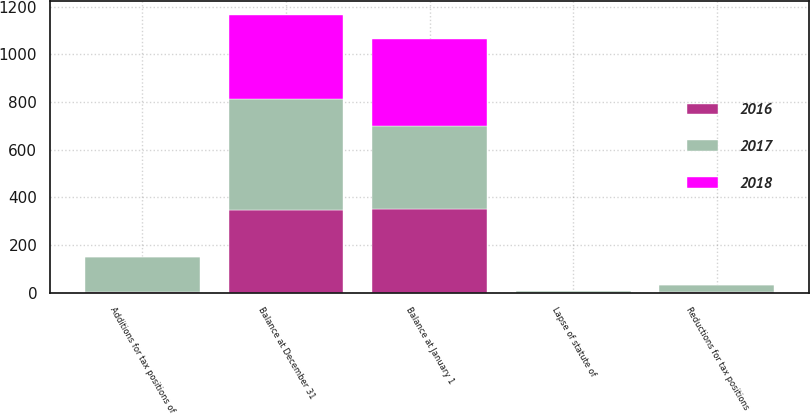<chart> <loc_0><loc_0><loc_500><loc_500><stacked_bar_chart><ecel><fcel>Balance at January 1<fcel>Additions for tax positions of<fcel>Reductions for tax positions<fcel>Lapse of statute of<fcel>Balance at December 31<nl><fcel>2017<fcel>348<fcel>146<fcel>26<fcel>7<fcel>463<nl><fcel>2016<fcel>352<fcel>2<fcel>5<fcel>1<fcel>348<nl><fcel>2018<fcel>364<fcel>1<fcel>1<fcel>1<fcel>352<nl></chart> 